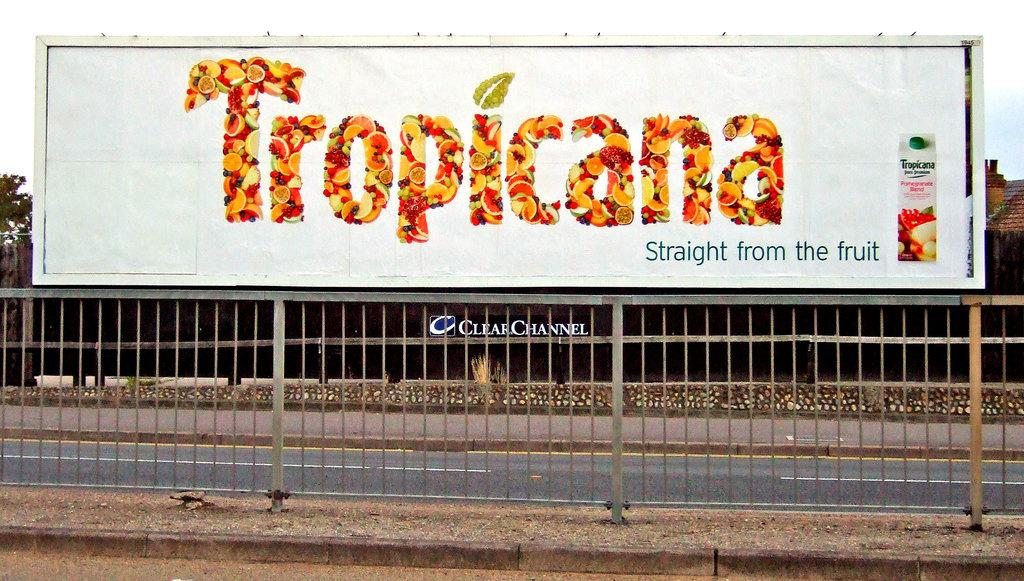<image>
Describe the image concisely. a large billboard that says 'tropicana' on it 